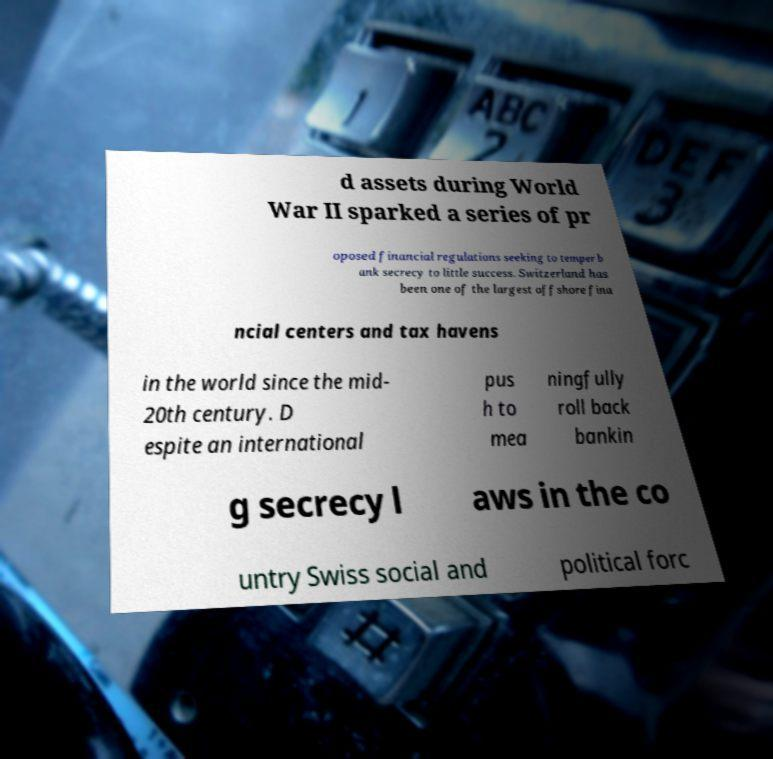Please identify and transcribe the text found in this image. d assets during World War II sparked a series of pr oposed financial regulations seeking to temper b ank secrecy to little success. Switzerland has been one of the largest offshore fina ncial centers and tax havens in the world since the mid- 20th century. D espite an international pus h to mea ningfully roll back bankin g secrecy l aws in the co untry Swiss social and political forc 